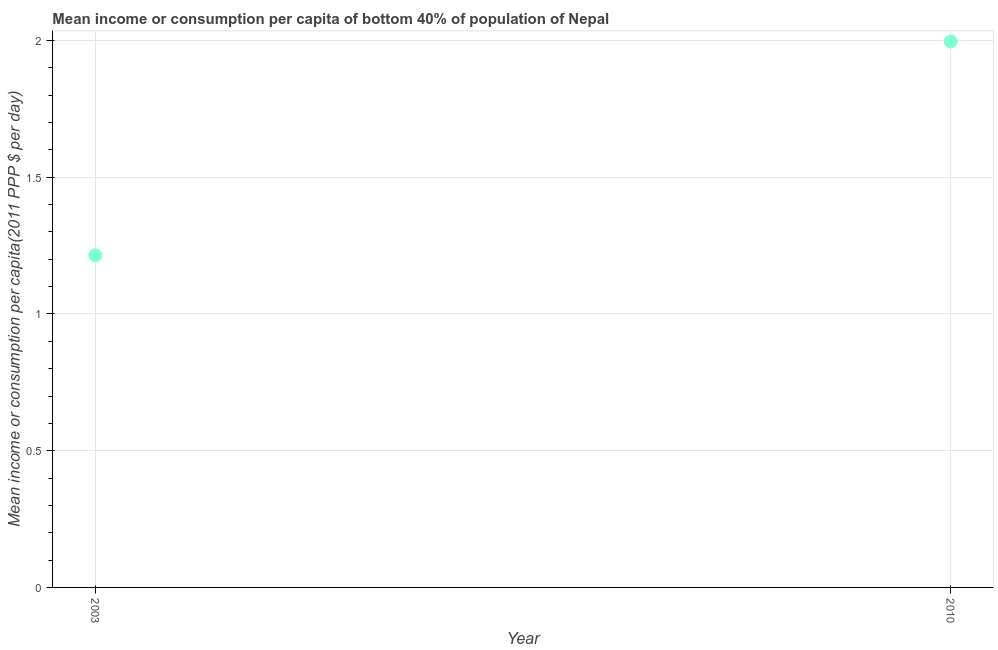What is the mean income or consumption in 2010?
Your answer should be compact. 2. Across all years, what is the maximum mean income or consumption?
Offer a very short reply. 2. Across all years, what is the minimum mean income or consumption?
Offer a terse response. 1.21. In which year was the mean income or consumption minimum?
Provide a succinct answer. 2003. What is the sum of the mean income or consumption?
Your response must be concise. 3.21. What is the difference between the mean income or consumption in 2003 and 2010?
Offer a very short reply. -0.78. What is the average mean income or consumption per year?
Offer a very short reply. 1.61. What is the median mean income or consumption?
Make the answer very short. 1.61. What is the ratio of the mean income or consumption in 2003 to that in 2010?
Offer a terse response. 0.61. In how many years, is the mean income or consumption greater than the average mean income or consumption taken over all years?
Your answer should be very brief. 1. How many dotlines are there?
Provide a succinct answer. 1. How many years are there in the graph?
Your answer should be very brief. 2. Are the values on the major ticks of Y-axis written in scientific E-notation?
Keep it short and to the point. No. Does the graph contain any zero values?
Give a very brief answer. No. Does the graph contain grids?
Offer a very short reply. Yes. What is the title of the graph?
Give a very brief answer. Mean income or consumption per capita of bottom 40% of population of Nepal. What is the label or title of the X-axis?
Offer a terse response. Year. What is the label or title of the Y-axis?
Give a very brief answer. Mean income or consumption per capita(2011 PPP $ per day). What is the Mean income or consumption per capita(2011 PPP $ per day) in 2003?
Your response must be concise. 1.21. What is the Mean income or consumption per capita(2011 PPP $ per day) in 2010?
Your response must be concise. 2. What is the difference between the Mean income or consumption per capita(2011 PPP $ per day) in 2003 and 2010?
Your answer should be very brief. -0.78. What is the ratio of the Mean income or consumption per capita(2011 PPP $ per day) in 2003 to that in 2010?
Make the answer very short. 0.61. 